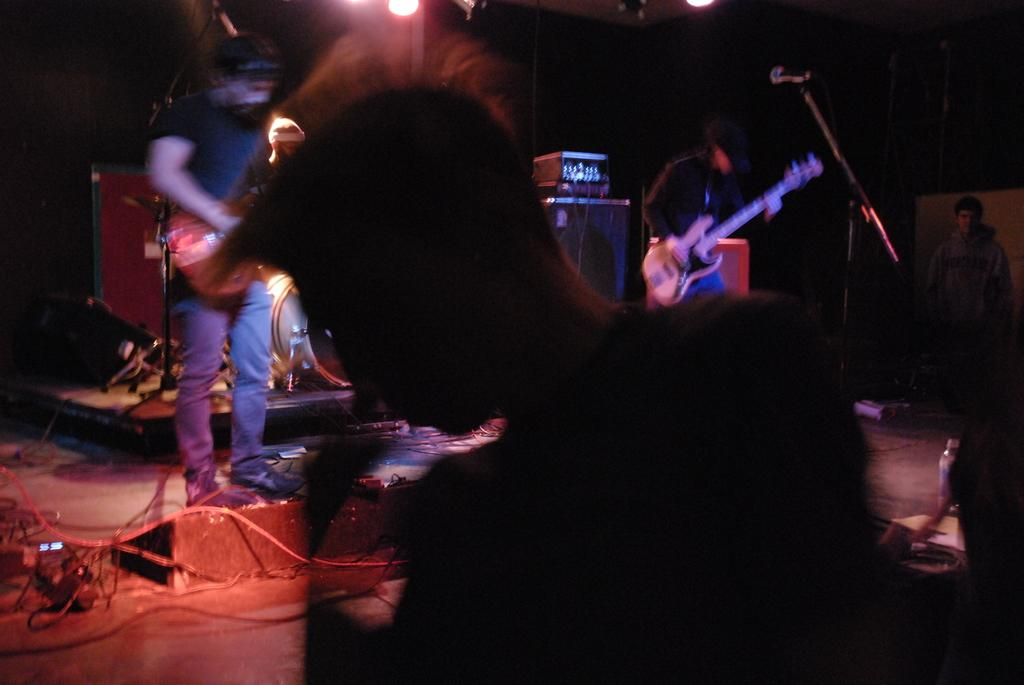How many people are in the image? There are two men in the image. What are the men doing in the image? The men are standing, and one of them is playing a guitar. Can you describe any objects related to music in the image? Yes, there is a microphone in the image. What type of cactus can be seen in the background of the image? There is no cactus present in the image. How many parcels are being delivered to the men in the image? There is no mention of parcels or delivery in the image. 